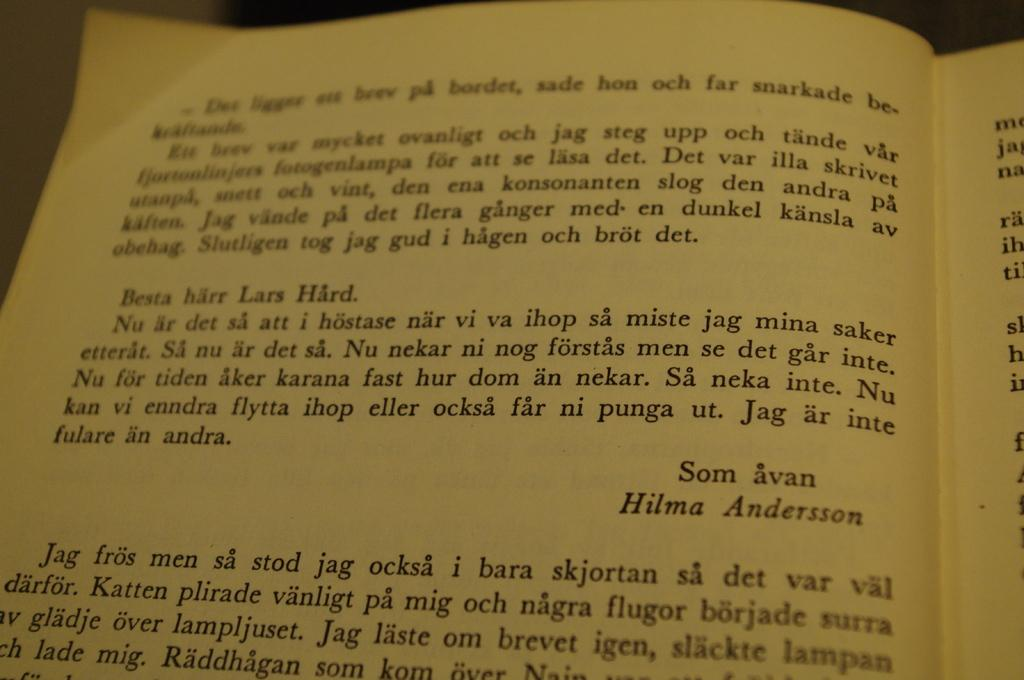<image>
Relay a brief, clear account of the picture shown. The name shown on the page of the book is Hilma Andersson 